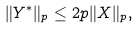Convert formula to latex. <formula><loc_0><loc_0><loc_500><loc_500>\| Y ^ { * } \| _ { p } \leq 2 p \| X \| _ { p } ,</formula> 